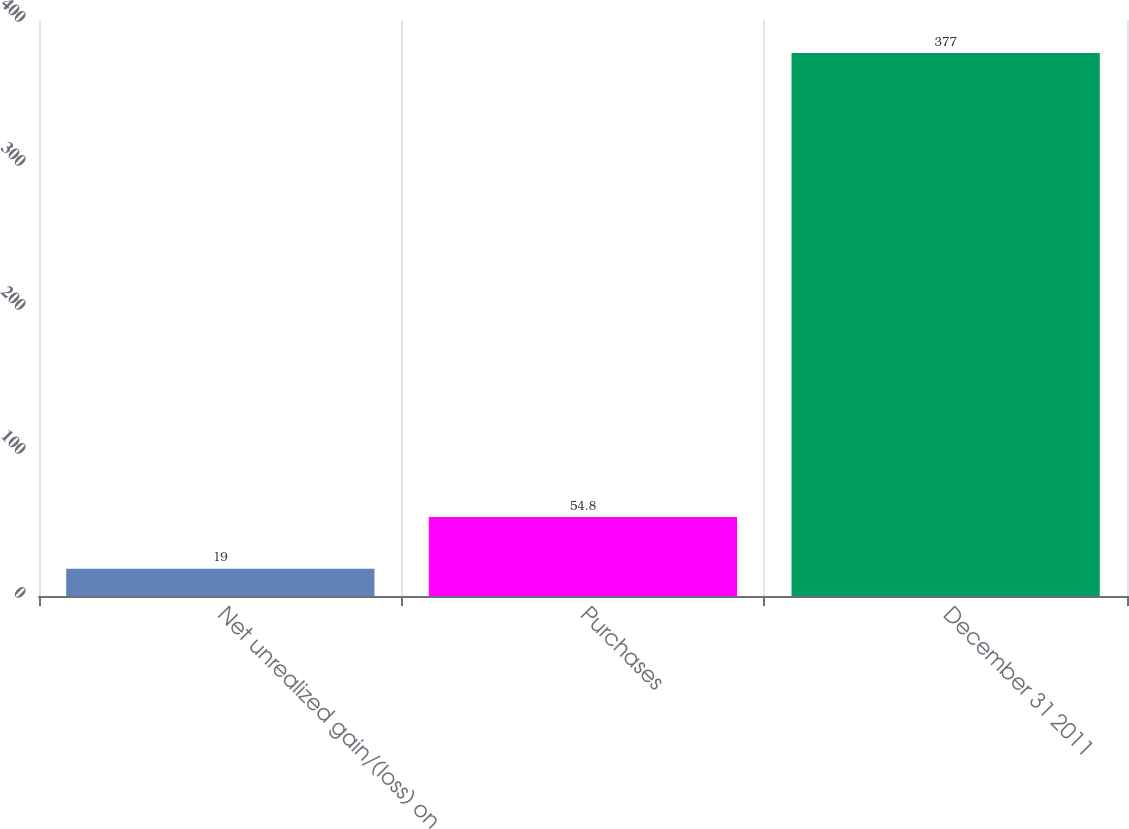Convert chart to OTSL. <chart><loc_0><loc_0><loc_500><loc_500><bar_chart><fcel>Net unrealized gain/(loss) on<fcel>Purchases<fcel>December 31 2011<nl><fcel>19<fcel>54.8<fcel>377<nl></chart> 